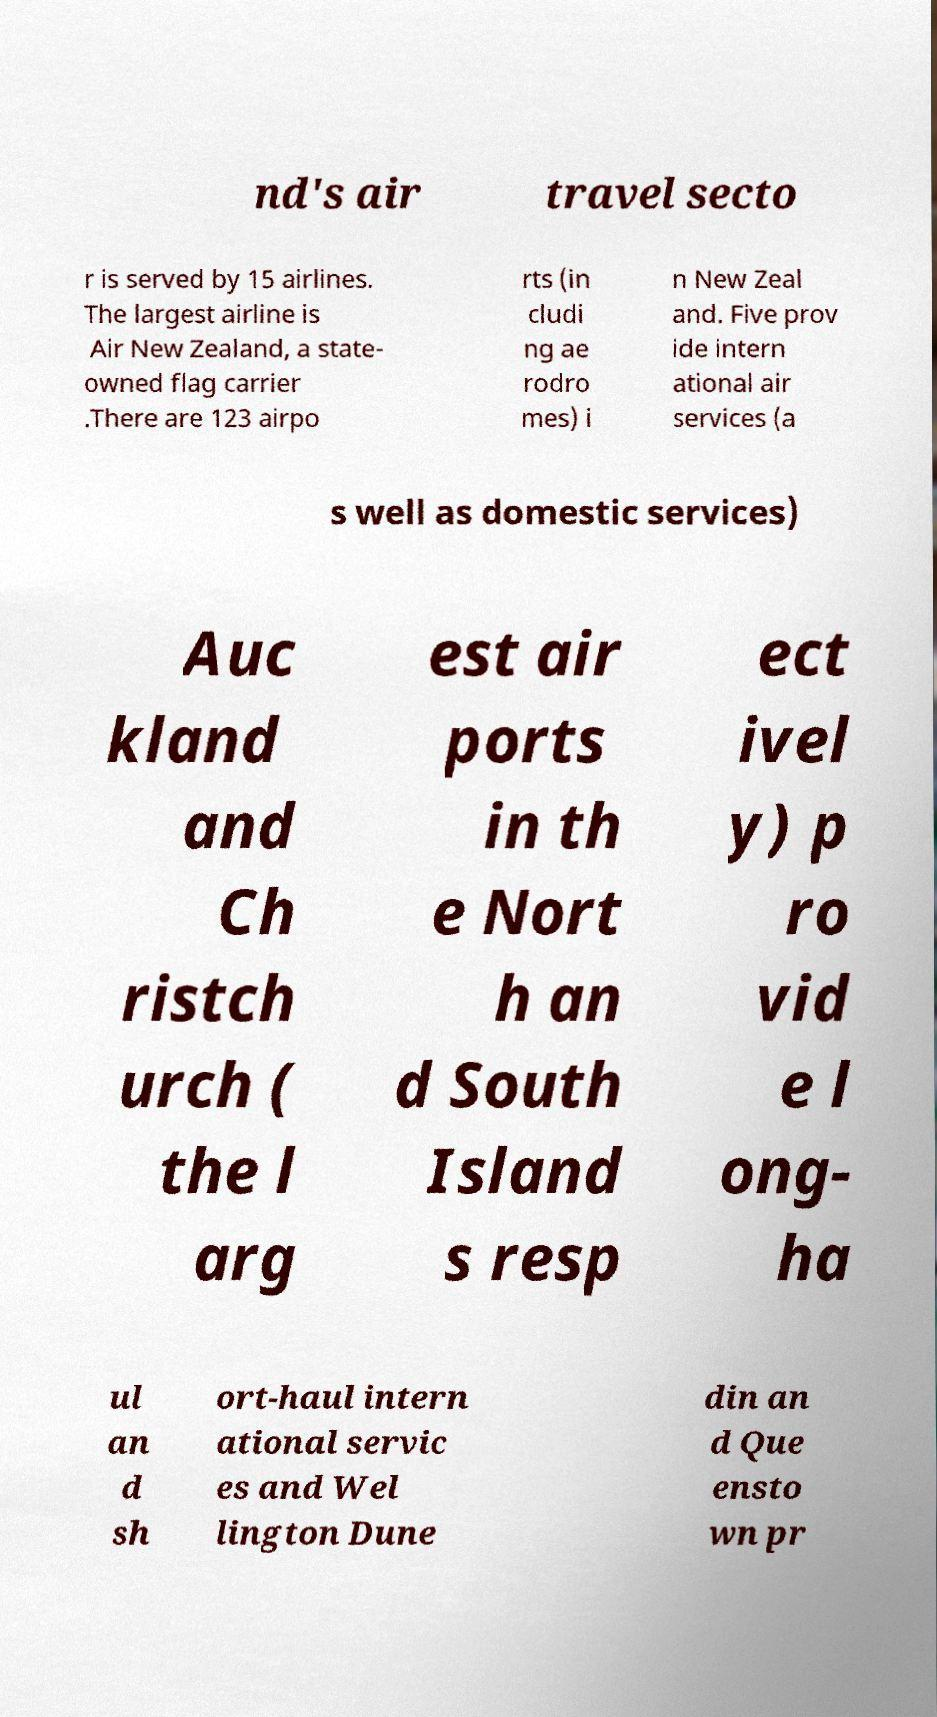For documentation purposes, I need the text within this image transcribed. Could you provide that? nd's air travel secto r is served by 15 airlines. The largest airline is Air New Zealand, a state- owned flag carrier .There are 123 airpo rts (in cludi ng ae rodro mes) i n New Zeal and. Five prov ide intern ational air services (a s well as domestic services) Auc kland and Ch ristch urch ( the l arg est air ports in th e Nort h an d South Island s resp ect ivel y) p ro vid e l ong- ha ul an d sh ort-haul intern ational servic es and Wel lington Dune din an d Que ensto wn pr 